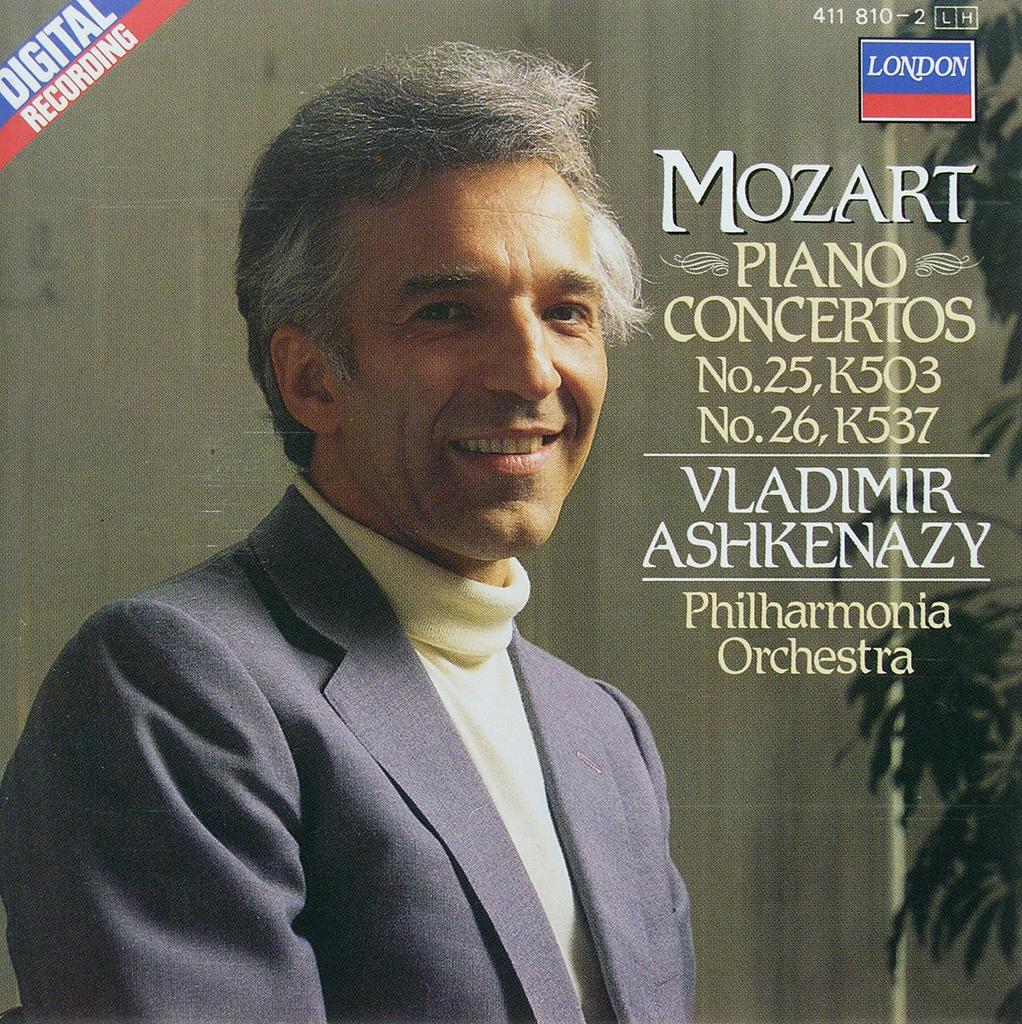<image>
Describe the image concisely. A CD with a man on front titled Mozart Piano Concertos. 